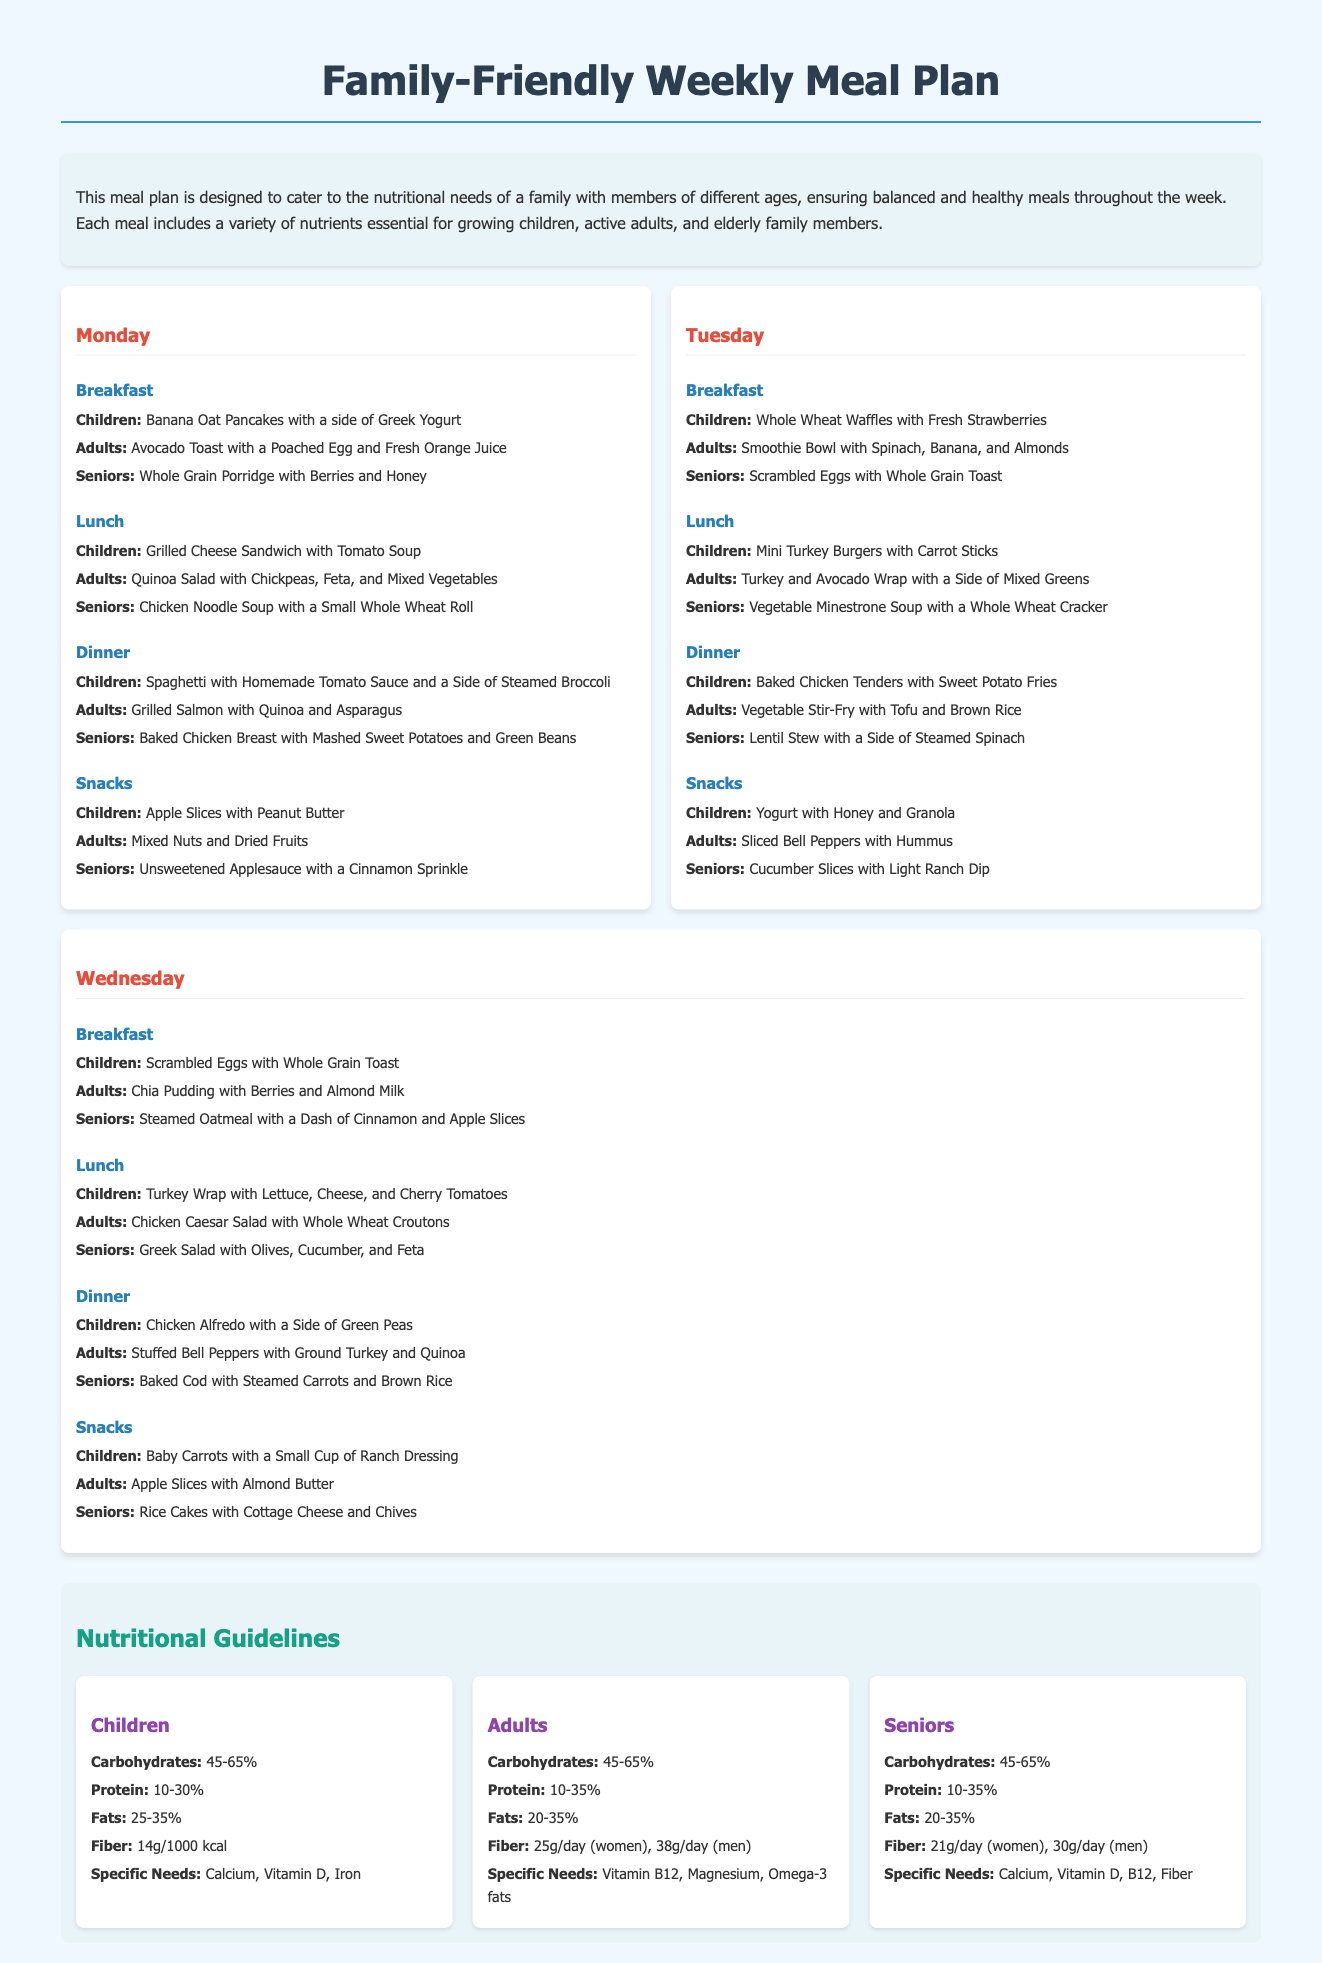What breakfast is recommended for children on Monday? The document lists breakfast options for children on Monday, which include Banana Oat Pancakes with a side of Greek Yogurt.
Answer: Banana Oat Pancakes with a side of Greek Yogurt What is the dinner option for seniors on Tuesday? The dinner option for seniors on Tuesday according to the meal plan is Lentil Stew with a Side of Steamed Spinach.
Answer: Lentil Stew with a Side of Steamed Spinach What percentage of carbohydrates is recommended for adults? The nutritional guidelines specify that adults should have 45-65% of their diet from carbohydrates.
Answer: 45-65% Which food item is used as a snack for adults on Wednesday? For adults on Wednesday, the snack mentioned is Apple Slices with Almond Butter.
Answer: Apple Slices with Almond Butter How many grams of fiber are recommended daily for women seniors? The guidelines state that women seniors should consume 21 grams of fiber per day.
Answer: 21g What is the lunch option for children on Monday? The meal plan indicates that children will have Grilled Cheese Sandwich with Tomato Soup for lunch on Monday.
Answer: Grilled Cheese Sandwich with Tomato Soup What type of soup is served for seniors’ lunch on Monday? The document specifies that seniors will have Chicken Noodle Soup with a Small Whole Wheat Roll for lunch on Monday.
Answer: Chicken Noodle Soup with a Small Whole Wheat Roll What is a significant nutritional need for children? According to the guidelines, a significant nutritional need for children is Calcium, Vitamin D, and Iron.
Answer: Calcium, Vitamin D, Iron What meal plan category does the document fall under? The document is categorized under a Family-Friendly Weekly Meal Plan designed for different age groups.
Answer: Family-Friendly Weekly Meal Plan 